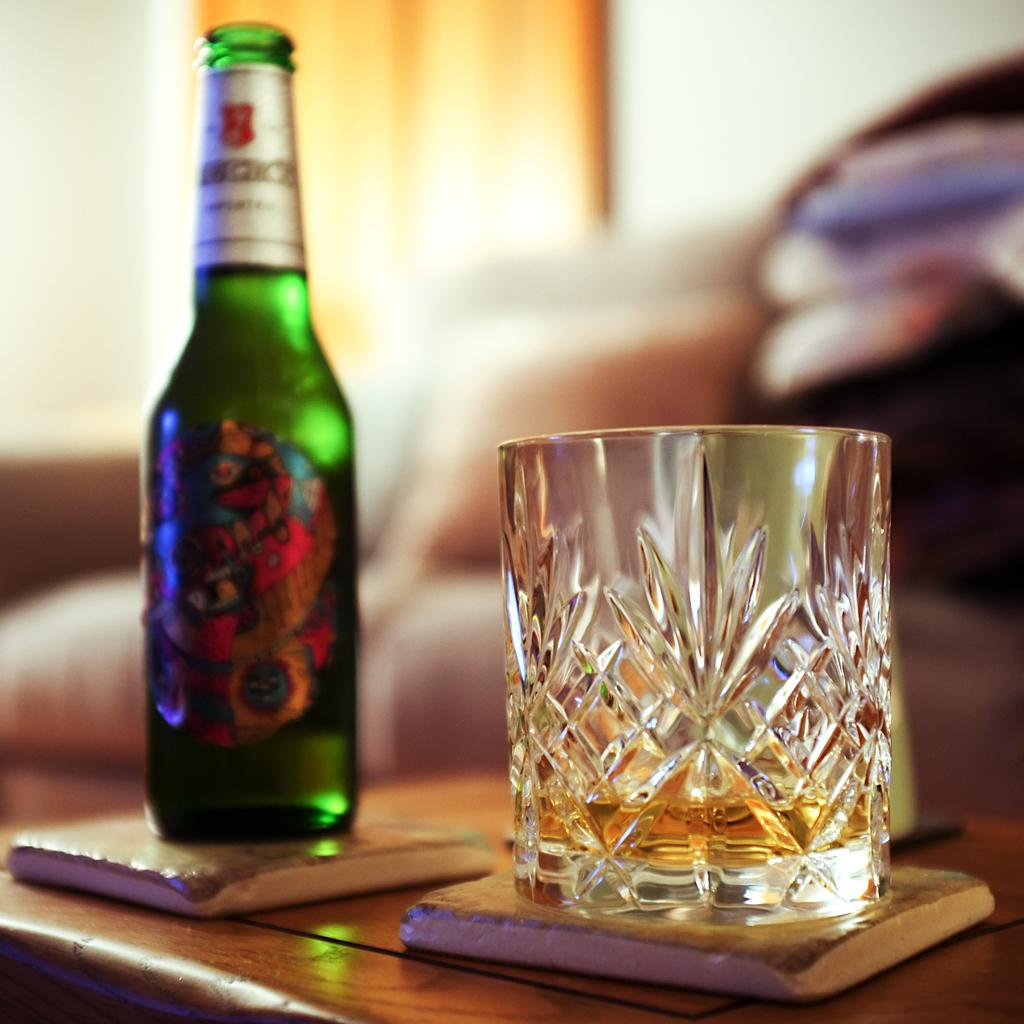<image>
Write a terse but informative summary of the picture. Empty cup next to a bottle in the back with a letter C in the name. 